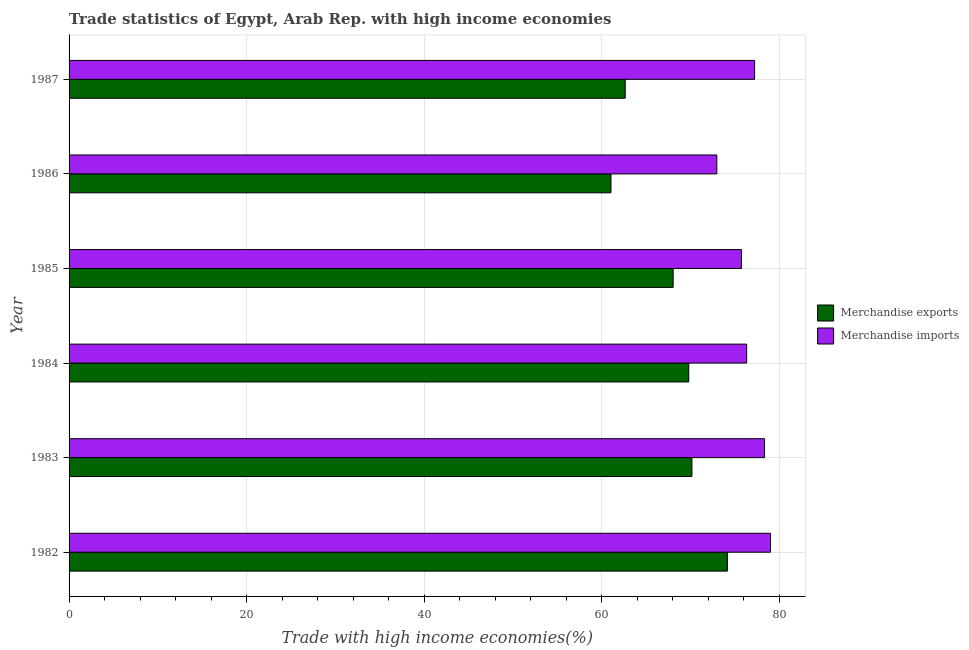How many different coloured bars are there?
Give a very brief answer. 2. How many bars are there on the 3rd tick from the bottom?
Your response must be concise. 2. What is the merchandise exports in 1982?
Your response must be concise. 74.17. Across all years, what is the maximum merchandise imports?
Ensure brevity in your answer.  79.02. Across all years, what is the minimum merchandise exports?
Provide a succinct answer. 61.05. In which year was the merchandise exports maximum?
Ensure brevity in your answer.  1982. In which year was the merchandise exports minimum?
Your response must be concise. 1986. What is the total merchandise exports in the graph?
Give a very brief answer. 405.9. What is the difference between the merchandise imports in 1982 and that in 1983?
Keep it short and to the point. 0.68. What is the difference between the merchandise imports in 1985 and the merchandise exports in 1984?
Give a very brief answer. 5.93. What is the average merchandise imports per year?
Make the answer very short. 76.61. In the year 1986, what is the difference between the merchandise exports and merchandise imports?
Your response must be concise. -11.92. What is the ratio of the merchandise imports in 1983 to that in 1987?
Your response must be concise. 1.01. Is the merchandise imports in 1983 less than that in 1985?
Give a very brief answer. No. Is the difference between the merchandise exports in 1982 and 1983 greater than the difference between the merchandise imports in 1982 and 1983?
Make the answer very short. Yes. What is the difference between the highest and the second highest merchandise exports?
Make the answer very short. 4. What is the difference between the highest and the lowest merchandise exports?
Offer a terse response. 13.12. Is the sum of the merchandise imports in 1982 and 1984 greater than the maximum merchandise exports across all years?
Offer a very short reply. Yes. What does the 2nd bar from the bottom in 1985 represents?
Offer a terse response. Merchandise imports. What is the difference between two consecutive major ticks on the X-axis?
Offer a terse response. 20. Are the values on the major ticks of X-axis written in scientific E-notation?
Keep it short and to the point. No. Where does the legend appear in the graph?
Your response must be concise. Center right. How many legend labels are there?
Make the answer very short. 2. What is the title of the graph?
Your response must be concise. Trade statistics of Egypt, Arab Rep. with high income economies. What is the label or title of the X-axis?
Your answer should be very brief. Trade with high income economies(%). What is the label or title of the Y-axis?
Ensure brevity in your answer.  Year. What is the Trade with high income economies(%) of Merchandise exports in 1982?
Your response must be concise. 74.17. What is the Trade with high income economies(%) in Merchandise imports in 1982?
Give a very brief answer. 79.02. What is the Trade with high income economies(%) in Merchandise exports in 1983?
Offer a terse response. 70.17. What is the Trade with high income economies(%) of Merchandise imports in 1983?
Your answer should be compact. 78.35. What is the Trade with high income economies(%) in Merchandise exports in 1984?
Provide a short and direct response. 69.81. What is the Trade with high income economies(%) in Merchandise imports in 1984?
Offer a very short reply. 76.33. What is the Trade with high income economies(%) of Merchandise exports in 1985?
Your answer should be compact. 68.05. What is the Trade with high income economies(%) of Merchandise imports in 1985?
Your answer should be compact. 75.74. What is the Trade with high income economies(%) of Merchandise exports in 1986?
Provide a short and direct response. 61.05. What is the Trade with high income economies(%) in Merchandise imports in 1986?
Offer a very short reply. 72.97. What is the Trade with high income economies(%) in Merchandise exports in 1987?
Offer a terse response. 62.65. What is the Trade with high income economies(%) of Merchandise imports in 1987?
Keep it short and to the point. 77.23. Across all years, what is the maximum Trade with high income economies(%) in Merchandise exports?
Make the answer very short. 74.17. Across all years, what is the maximum Trade with high income economies(%) of Merchandise imports?
Keep it short and to the point. 79.02. Across all years, what is the minimum Trade with high income economies(%) of Merchandise exports?
Make the answer very short. 61.05. Across all years, what is the minimum Trade with high income economies(%) of Merchandise imports?
Make the answer very short. 72.97. What is the total Trade with high income economies(%) of Merchandise exports in the graph?
Provide a short and direct response. 405.9. What is the total Trade with high income economies(%) of Merchandise imports in the graph?
Offer a very short reply. 459.64. What is the difference between the Trade with high income economies(%) in Merchandise exports in 1982 and that in 1983?
Provide a succinct answer. 4. What is the difference between the Trade with high income economies(%) in Merchandise imports in 1982 and that in 1983?
Keep it short and to the point. 0.68. What is the difference between the Trade with high income economies(%) in Merchandise exports in 1982 and that in 1984?
Keep it short and to the point. 4.35. What is the difference between the Trade with high income economies(%) in Merchandise imports in 1982 and that in 1984?
Give a very brief answer. 2.69. What is the difference between the Trade with high income economies(%) in Merchandise exports in 1982 and that in 1985?
Make the answer very short. 6.11. What is the difference between the Trade with high income economies(%) in Merchandise imports in 1982 and that in 1985?
Offer a terse response. 3.28. What is the difference between the Trade with high income economies(%) of Merchandise exports in 1982 and that in 1986?
Offer a very short reply. 13.12. What is the difference between the Trade with high income economies(%) of Merchandise imports in 1982 and that in 1986?
Ensure brevity in your answer.  6.05. What is the difference between the Trade with high income economies(%) of Merchandise exports in 1982 and that in 1987?
Provide a succinct answer. 11.51. What is the difference between the Trade with high income economies(%) of Merchandise imports in 1982 and that in 1987?
Offer a terse response. 1.79. What is the difference between the Trade with high income economies(%) in Merchandise exports in 1983 and that in 1984?
Provide a succinct answer. 0.36. What is the difference between the Trade with high income economies(%) of Merchandise imports in 1983 and that in 1984?
Provide a short and direct response. 2.01. What is the difference between the Trade with high income economies(%) in Merchandise exports in 1983 and that in 1985?
Your response must be concise. 2.11. What is the difference between the Trade with high income economies(%) of Merchandise imports in 1983 and that in 1985?
Give a very brief answer. 2.6. What is the difference between the Trade with high income economies(%) of Merchandise exports in 1983 and that in 1986?
Ensure brevity in your answer.  9.12. What is the difference between the Trade with high income economies(%) of Merchandise imports in 1983 and that in 1986?
Your response must be concise. 5.37. What is the difference between the Trade with high income economies(%) of Merchandise exports in 1983 and that in 1987?
Offer a very short reply. 7.51. What is the difference between the Trade with high income economies(%) in Merchandise imports in 1983 and that in 1987?
Provide a short and direct response. 1.12. What is the difference between the Trade with high income economies(%) in Merchandise exports in 1984 and that in 1985?
Make the answer very short. 1.76. What is the difference between the Trade with high income economies(%) of Merchandise imports in 1984 and that in 1985?
Provide a succinct answer. 0.59. What is the difference between the Trade with high income economies(%) of Merchandise exports in 1984 and that in 1986?
Keep it short and to the point. 8.76. What is the difference between the Trade with high income economies(%) in Merchandise imports in 1984 and that in 1986?
Keep it short and to the point. 3.36. What is the difference between the Trade with high income economies(%) of Merchandise exports in 1984 and that in 1987?
Provide a short and direct response. 7.16. What is the difference between the Trade with high income economies(%) in Merchandise imports in 1984 and that in 1987?
Provide a short and direct response. -0.89. What is the difference between the Trade with high income economies(%) in Merchandise exports in 1985 and that in 1986?
Give a very brief answer. 7. What is the difference between the Trade with high income economies(%) in Merchandise imports in 1985 and that in 1986?
Your answer should be very brief. 2.77. What is the difference between the Trade with high income economies(%) of Merchandise exports in 1985 and that in 1987?
Your response must be concise. 5.4. What is the difference between the Trade with high income economies(%) of Merchandise imports in 1985 and that in 1987?
Provide a short and direct response. -1.48. What is the difference between the Trade with high income economies(%) in Merchandise exports in 1986 and that in 1987?
Your response must be concise. -1.61. What is the difference between the Trade with high income economies(%) in Merchandise imports in 1986 and that in 1987?
Provide a succinct answer. -4.26. What is the difference between the Trade with high income economies(%) of Merchandise exports in 1982 and the Trade with high income economies(%) of Merchandise imports in 1983?
Your answer should be compact. -4.18. What is the difference between the Trade with high income economies(%) in Merchandise exports in 1982 and the Trade with high income economies(%) in Merchandise imports in 1984?
Your response must be concise. -2.17. What is the difference between the Trade with high income economies(%) of Merchandise exports in 1982 and the Trade with high income economies(%) of Merchandise imports in 1985?
Give a very brief answer. -1.58. What is the difference between the Trade with high income economies(%) of Merchandise exports in 1982 and the Trade with high income economies(%) of Merchandise imports in 1986?
Offer a terse response. 1.19. What is the difference between the Trade with high income economies(%) of Merchandise exports in 1982 and the Trade with high income economies(%) of Merchandise imports in 1987?
Keep it short and to the point. -3.06. What is the difference between the Trade with high income economies(%) of Merchandise exports in 1983 and the Trade with high income economies(%) of Merchandise imports in 1984?
Your response must be concise. -6.17. What is the difference between the Trade with high income economies(%) of Merchandise exports in 1983 and the Trade with high income economies(%) of Merchandise imports in 1985?
Offer a terse response. -5.58. What is the difference between the Trade with high income economies(%) in Merchandise exports in 1983 and the Trade with high income economies(%) in Merchandise imports in 1986?
Ensure brevity in your answer.  -2.81. What is the difference between the Trade with high income economies(%) of Merchandise exports in 1983 and the Trade with high income economies(%) of Merchandise imports in 1987?
Provide a succinct answer. -7.06. What is the difference between the Trade with high income economies(%) of Merchandise exports in 1984 and the Trade with high income economies(%) of Merchandise imports in 1985?
Offer a very short reply. -5.93. What is the difference between the Trade with high income economies(%) in Merchandise exports in 1984 and the Trade with high income economies(%) in Merchandise imports in 1986?
Give a very brief answer. -3.16. What is the difference between the Trade with high income economies(%) in Merchandise exports in 1984 and the Trade with high income economies(%) in Merchandise imports in 1987?
Make the answer very short. -7.42. What is the difference between the Trade with high income economies(%) of Merchandise exports in 1985 and the Trade with high income economies(%) of Merchandise imports in 1986?
Make the answer very short. -4.92. What is the difference between the Trade with high income economies(%) in Merchandise exports in 1985 and the Trade with high income economies(%) in Merchandise imports in 1987?
Give a very brief answer. -9.18. What is the difference between the Trade with high income economies(%) in Merchandise exports in 1986 and the Trade with high income economies(%) in Merchandise imports in 1987?
Your answer should be very brief. -16.18. What is the average Trade with high income economies(%) of Merchandise exports per year?
Give a very brief answer. 67.65. What is the average Trade with high income economies(%) of Merchandise imports per year?
Make the answer very short. 76.61. In the year 1982, what is the difference between the Trade with high income economies(%) in Merchandise exports and Trade with high income economies(%) in Merchandise imports?
Give a very brief answer. -4.86. In the year 1983, what is the difference between the Trade with high income economies(%) in Merchandise exports and Trade with high income economies(%) in Merchandise imports?
Your response must be concise. -8.18. In the year 1984, what is the difference between the Trade with high income economies(%) of Merchandise exports and Trade with high income economies(%) of Merchandise imports?
Offer a very short reply. -6.52. In the year 1985, what is the difference between the Trade with high income economies(%) of Merchandise exports and Trade with high income economies(%) of Merchandise imports?
Your answer should be very brief. -7.69. In the year 1986, what is the difference between the Trade with high income economies(%) of Merchandise exports and Trade with high income economies(%) of Merchandise imports?
Offer a terse response. -11.92. In the year 1987, what is the difference between the Trade with high income economies(%) in Merchandise exports and Trade with high income economies(%) in Merchandise imports?
Keep it short and to the point. -14.57. What is the ratio of the Trade with high income economies(%) in Merchandise exports in 1982 to that in 1983?
Provide a succinct answer. 1.06. What is the ratio of the Trade with high income economies(%) in Merchandise imports in 1982 to that in 1983?
Make the answer very short. 1.01. What is the ratio of the Trade with high income economies(%) of Merchandise exports in 1982 to that in 1984?
Keep it short and to the point. 1.06. What is the ratio of the Trade with high income economies(%) of Merchandise imports in 1982 to that in 1984?
Provide a short and direct response. 1.04. What is the ratio of the Trade with high income economies(%) in Merchandise exports in 1982 to that in 1985?
Give a very brief answer. 1.09. What is the ratio of the Trade with high income economies(%) in Merchandise imports in 1982 to that in 1985?
Your answer should be compact. 1.04. What is the ratio of the Trade with high income economies(%) of Merchandise exports in 1982 to that in 1986?
Make the answer very short. 1.21. What is the ratio of the Trade with high income economies(%) in Merchandise imports in 1982 to that in 1986?
Give a very brief answer. 1.08. What is the ratio of the Trade with high income economies(%) in Merchandise exports in 1982 to that in 1987?
Keep it short and to the point. 1.18. What is the ratio of the Trade with high income economies(%) in Merchandise imports in 1982 to that in 1987?
Provide a short and direct response. 1.02. What is the ratio of the Trade with high income economies(%) of Merchandise imports in 1983 to that in 1984?
Give a very brief answer. 1.03. What is the ratio of the Trade with high income economies(%) of Merchandise exports in 1983 to that in 1985?
Ensure brevity in your answer.  1.03. What is the ratio of the Trade with high income economies(%) of Merchandise imports in 1983 to that in 1985?
Offer a terse response. 1.03. What is the ratio of the Trade with high income economies(%) in Merchandise exports in 1983 to that in 1986?
Give a very brief answer. 1.15. What is the ratio of the Trade with high income economies(%) of Merchandise imports in 1983 to that in 1986?
Offer a very short reply. 1.07. What is the ratio of the Trade with high income economies(%) of Merchandise exports in 1983 to that in 1987?
Offer a terse response. 1.12. What is the ratio of the Trade with high income economies(%) in Merchandise imports in 1983 to that in 1987?
Ensure brevity in your answer.  1.01. What is the ratio of the Trade with high income economies(%) of Merchandise exports in 1984 to that in 1985?
Your answer should be compact. 1.03. What is the ratio of the Trade with high income economies(%) in Merchandise imports in 1984 to that in 1985?
Your answer should be very brief. 1.01. What is the ratio of the Trade with high income economies(%) of Merchandise exports in 1984 to that in 1986?
Your response must be concise. 1.14. What is the ratio of the Trade with high income economies(%) in Merchandise imports in 1984 to that in 1986?
Offer a very short reply. 1.05. What is the ratio of the Trade with high income economies(%) of Merchandise exports in 1984 to that in 1987?
Ensure brevity in your answer.  1.11. What is the ratio of the Trade with high income economies(%) in Merchandise imports in 1984 to that in 1987?
Provide a succinct answer. 0.99. What is the ratio of the Trade with high income economies(%) of Merchandise exports in 1985 to that in 1986?
Give a very brief answer. 1.11. What is the ratio of the Trade with high income economies(%) of Merchandise imports in 1985 to that in 1986?
Ensure brevity in your answer.  1.04. What is the ratio of the Trade with high income economies(%) in Merchandise exports in 1985 to that in 1987?
Keep it short and to the point. 1.09. What is the ratio of the Trade with high income economies(%) of Merchandise imports in 1985 to that in 1987?
Give a very brief answer. 0.98. What is the ratio of the Trade with high income economies(%) of Merchandise exports in 1986 to that in 1987?
Provide a succinct answer. 0.97. What is the ratio of the Trade with high income economies(%) of Merchandise imports in 1986 to that in 1987?
Ensure brevity in your answer.  0.94. What is the difference between the highest and the second highest Trade with high income economies(%) in Merchandise exports?
Ensure brevity in your answer.  4. What is the difference between the highest and the second highest Trade with high income economies(%) in Merchandise imports?
Keep it short and to the point. 0.68. What is the difference between the highest and the lowest Trade with high income economies(%) of Merchandise exports?
Keep it short and to the point. 13.12. What is the difference between the highest and the lowest Trade with high income economies(%) in Merchandise imports?
Give a very brief answer. 6.05. 